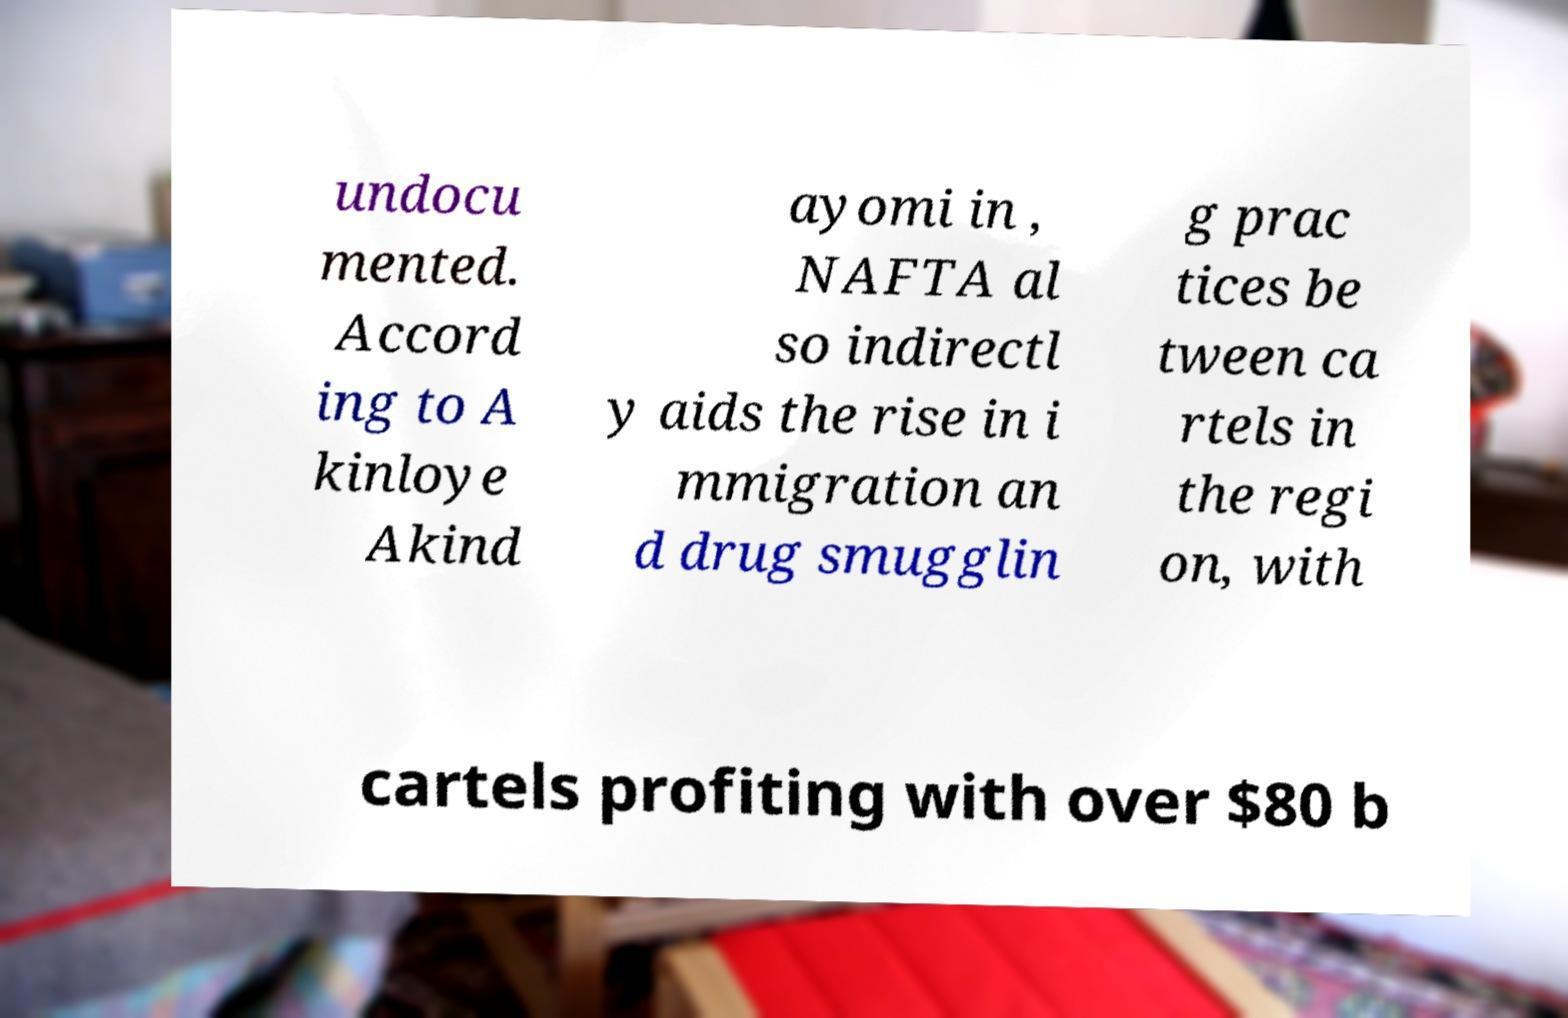Could you assist in decoding the text presented in this image and type it out clearly? undocu mented. Accord ing to A kinloye Akind ayomi in , NAFTA al so indirectl y aids the rise in i mmigration an d drug smugglin g prac tices be tween ca rtels in the regi on, with cartels profiting with over $80 b 